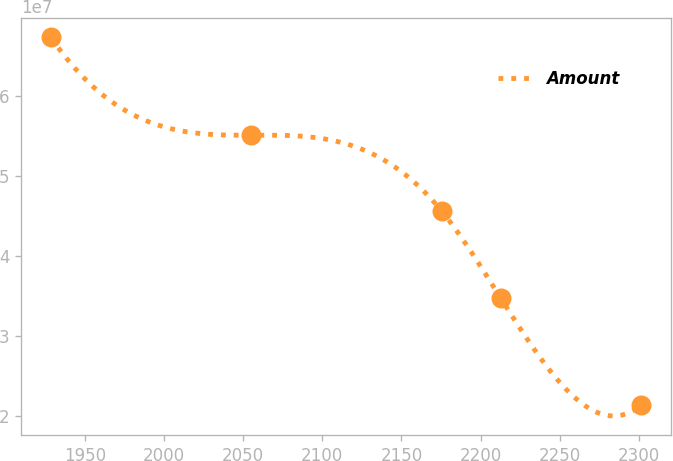<chart> <loc_0><loc_0><loc_500><loc_500><line_chart><ecel><fcel>Amount<nl><fcel>1928.5<fcel>6.73097e+07<nl><fcel>2054.96<fcel>5.50974e+07<nl><fcel>2175.34<fcel>4.56414e+07<nl><fcel>2212.65<fcel>3.47769e+07<nl><fcel>2301.58<fcel>2.14363e+07<nl></chart> 